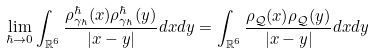<formula> <loc_0><loc_0><loc_500><loc_500>\lim _ { \hbar { \to } 0 } \int _ { \mathbb { R } ^ { 6 } } \frac { \rho _ { \gamma _ { \hbar } } ^ { \hbar } ( x ) \rho _ { \gamma _ { \hbar } } ^ { \hbar } ( y ) } { | x - y | } d x d y = \int _ { \mathbb { R } ^ { 6 } } \frac { \rho _ { \mathcal { Q } } ( x ) \rho _ { \mathcal { Q } } ( y ) } { | x - y | } d x d y</formula> 